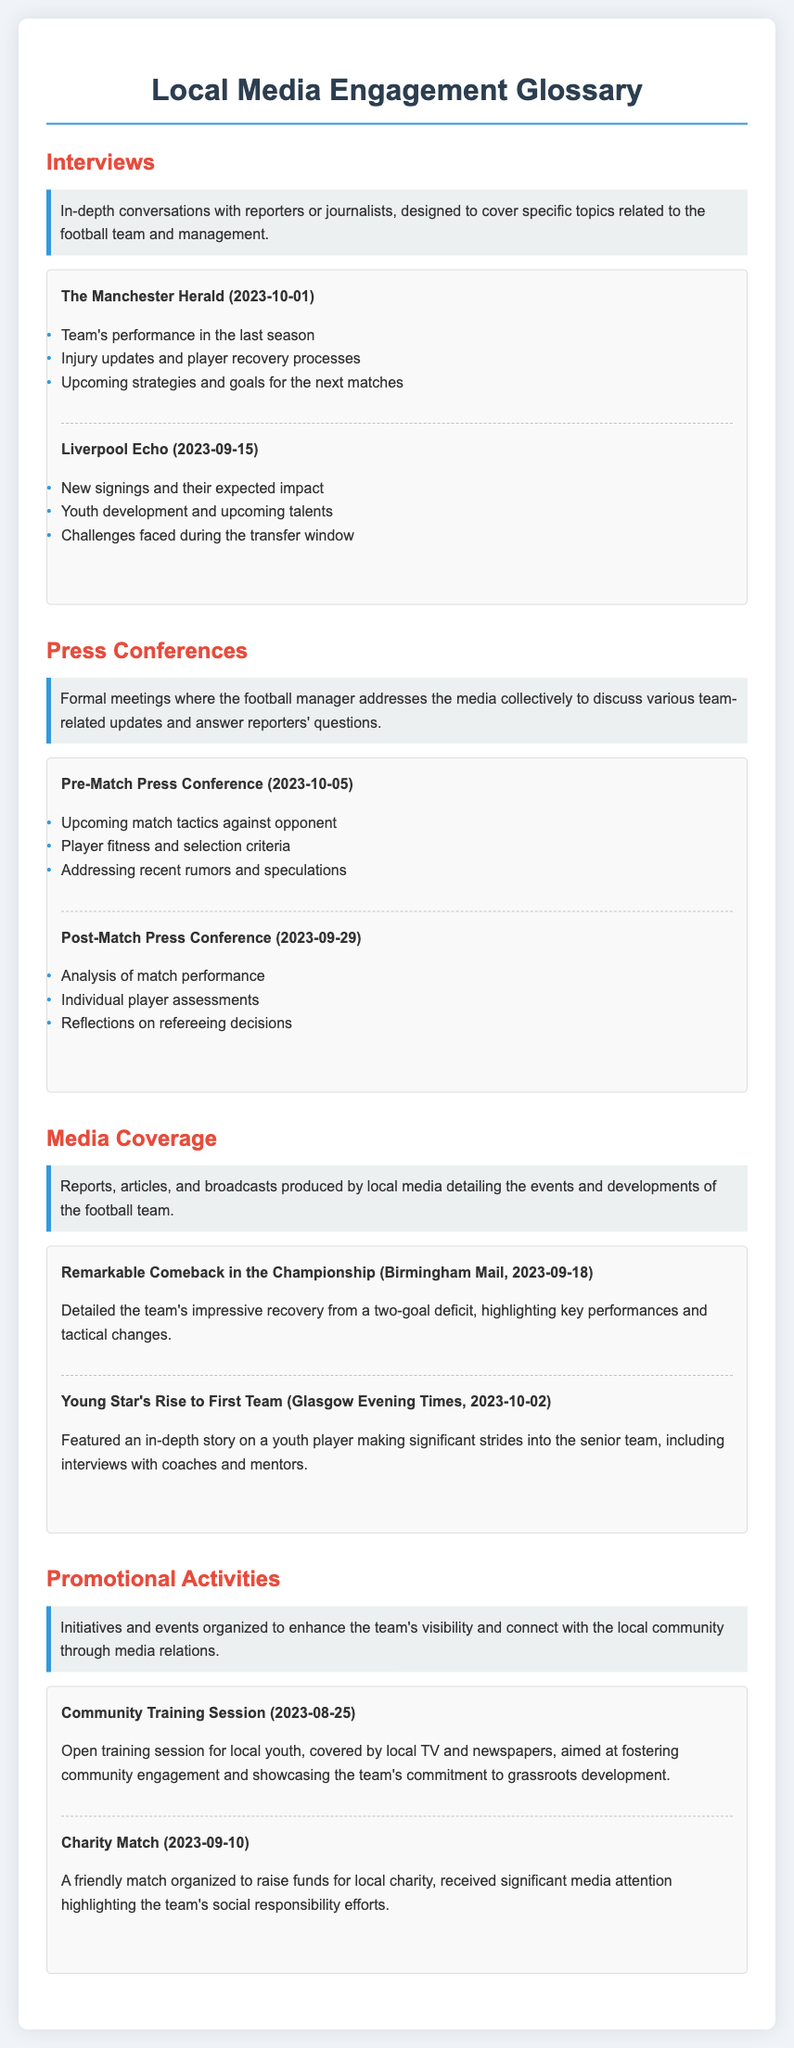What are interviews? Interviews are in-depth conversations with reporters or journalists, designed to cover specific topics related to the football team and management.
Answer: In-depth conversations When was the pre-match press conference held? The date of the pre-match press conference is specified in the document under the examples.
Answer: 2023-10-05 What is the focus of media coverage? The focus of media coverage includes reports, articles, and broadcasts produced by local media detailing the events and developments of the football team.
Answer: Events and developments What was one key point discussed in the Manchester Herald interview? The document lists key points discussed in the interview, highlighting the specifics of the topic.
Answer: Team's performance in the last season What type of initiative is a community training session? The document categorizes this initiative under promotional activities, which aims to enhance visibility and community connection.
Answer: Promotional activity What was the main theme of the "Young Star's Rise to First Team" article? The theme is highlighted in the description of the media coverage example, focusing on youth development.
Answer: Youth player development How many examples of press conferences are provided? The document explicitly lists the number of examples under the press conferences section.
Answer: Two examples What is the purpose of promotional activities? The purpose is summarized in the definition of promotional activities, elaborating on community connection and visibility.
Answer: Enhance visibility and connect with the local community 